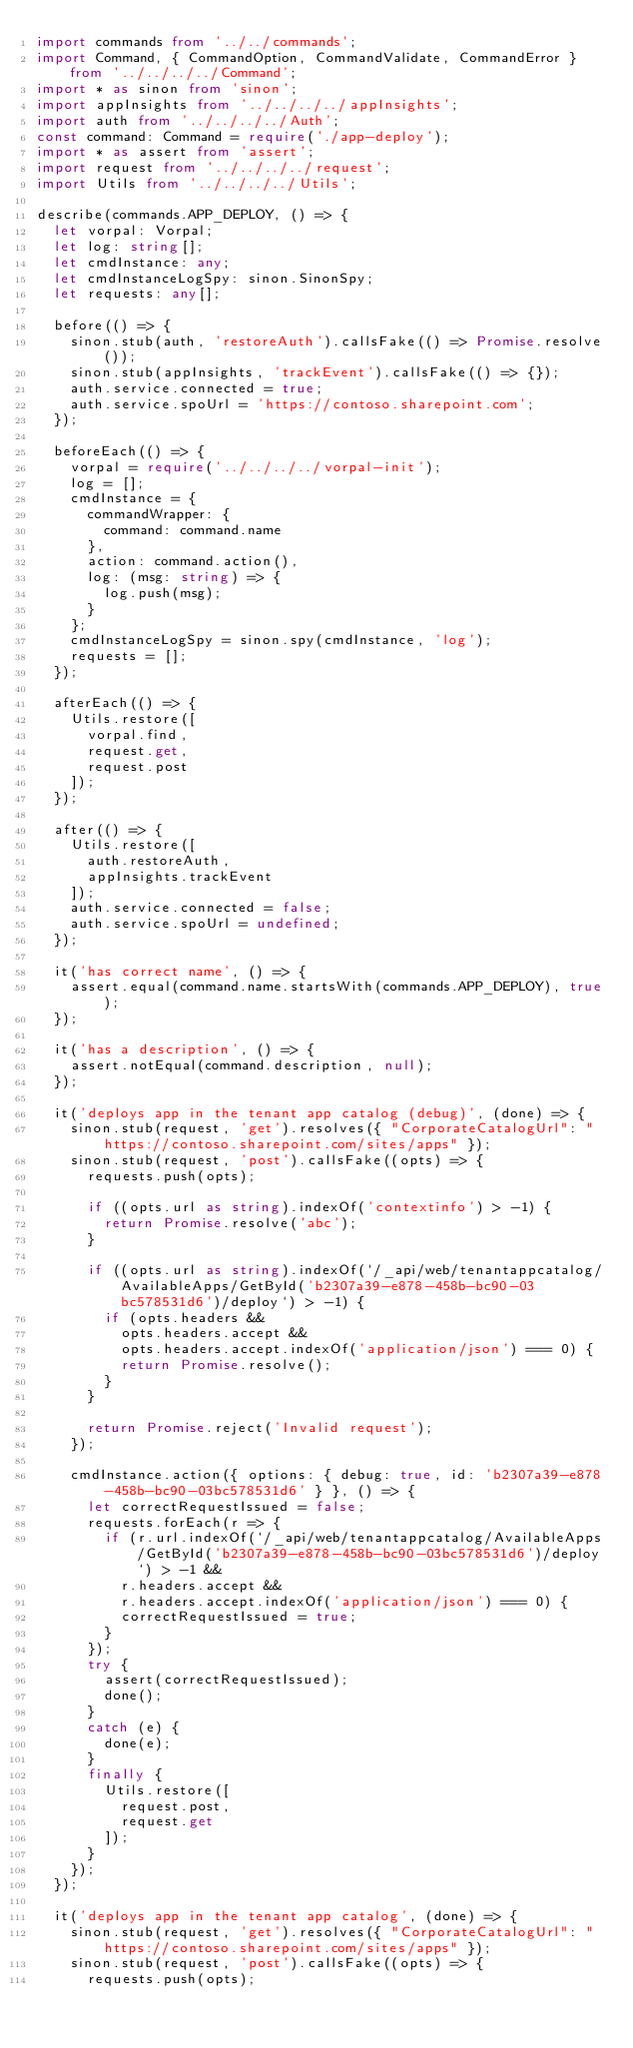Convert code to text. <code><loc_0><loc_0><loc_500><loc_500><_TypeScript_>import commands from '../../commands';
import Command, { CommandOption, CommandValidate, CommandError } from '../../../../Command';
import * as sinon from 'sinon';
import appInsights from '../../../../appInsights';
import auth from '../../../../Auth';
const command: Command = require('./app-deploy');
import * as assert from 'assert';
import request from '../../../../request';
import Utils from '../../../../Utils';

describe(commands.APP_DEPLOY, () => {
  let vorpal: Vorpal;
  let log: string[];
  let cmdInstance: any;
  let cmdInstanceLogSpy: sinon.SinonSpy;
  let requests: any[];

  before(() => {
    sinon.stub(auth, 'restoreAuth').callsFake(() => Promise.resolve());
    sinon.stub(appInsights, 'trackEvent').callsFake(() => {});
    auth.service.connected = true;
    auth.service.spoUrl = 'https://contoso.sharepoint.com';
  });

  beforeEach(() => {
    vorpal = require('../../../../vorpal-init');
    log = [];
    cmdInstance = {
      commandWrapper: {
        command: command.name
      },
      action: command.action(),
      log: (msg: string) => {
        log.push(msg);
      }
    };
    cmdInstanceLogSpy = sinon.spy(cmdInstance, 'log');
    requests = [];
  });

  afterEach(() => {
    Utils.restore([
      vorpal.find,
      request.get,
      request.post
    ]);
  });

  after(() => {
    Utils.restore([
      auth.restoreAuth,
      appInsights.trackEvent
    ]);
    auth.service.connected = false;
    auth.service.spoUrl = undefined;
  });

  it('has correct name', () => {
    assert.equal(command.name.startsWith(commands.APP_DEPLOY), true);
  });

  it('has a description', () => {
    assert.notEqual(command.description, null);
  });

  it('deploys app in the tenant app catalog (debug)', (done) => {
    sinon.stub(request, 'get').resolves({ "CorporateCatalogUrl": "https://contoso.sharepoint.com/sites/apps" });
    sinon.stub(request, 'post').callsFake((opts) => {
      requests.push(opts);

      if ((opts.url as string).indexOf('contextinfo') > -1) {
        return Promise.resolve('abc');
      }

      if ((opts.url as string).indexOf(`/_api/web/tenantappcatalog/AvailableApps/GetById('b2307a39-e878-458b-bc90-03bc578531d6')/deploy`) > -1) {
        if (opts.headers &&
          opts.headers.accept &&
          opts.headers.accept.indexOf('application/json') === 0) {
          return Promise.resolve();
        }
      }

      return Promise.reject('Invalid request');
    });

    cmdInstance.action({ options: { debug: true, id: 'b2307a39-e878-458b-bc90-03bc578531d6' } }, () => {
      let correctRequestIssued = false;
      requests.forEach(r => {
        if (r.url.indexOf(`/_api/web/tenantappcatalog/AvailableApps/GetById('b2307a39-e878-458b-bc90-03bc578531d6')/deploy`) > -1 &&
          r.headers.accept &&
          r.headers.accept.indexOf('application/json') === 0) {
          correctRequestIssued = true;
        }
      });
      try {
        assert(correctRequestIssued);
        done();
      }
      catch (e) {
        done(e);
      }
      finally {
        Utils.restore([
          request.post,
          request.get
        ]);
      }
    });
  });

  it('deploys app in the tenant app catalog', (done) => {
    sinon.stub(request, 'get').resolves({ "CorporateCatalogUrl": "https://contoso.sharepoint.com/sites/apps" });
    sinon.stub(request, 'post').callsFake((opts) => {
      requests.push(opts);
</code> 